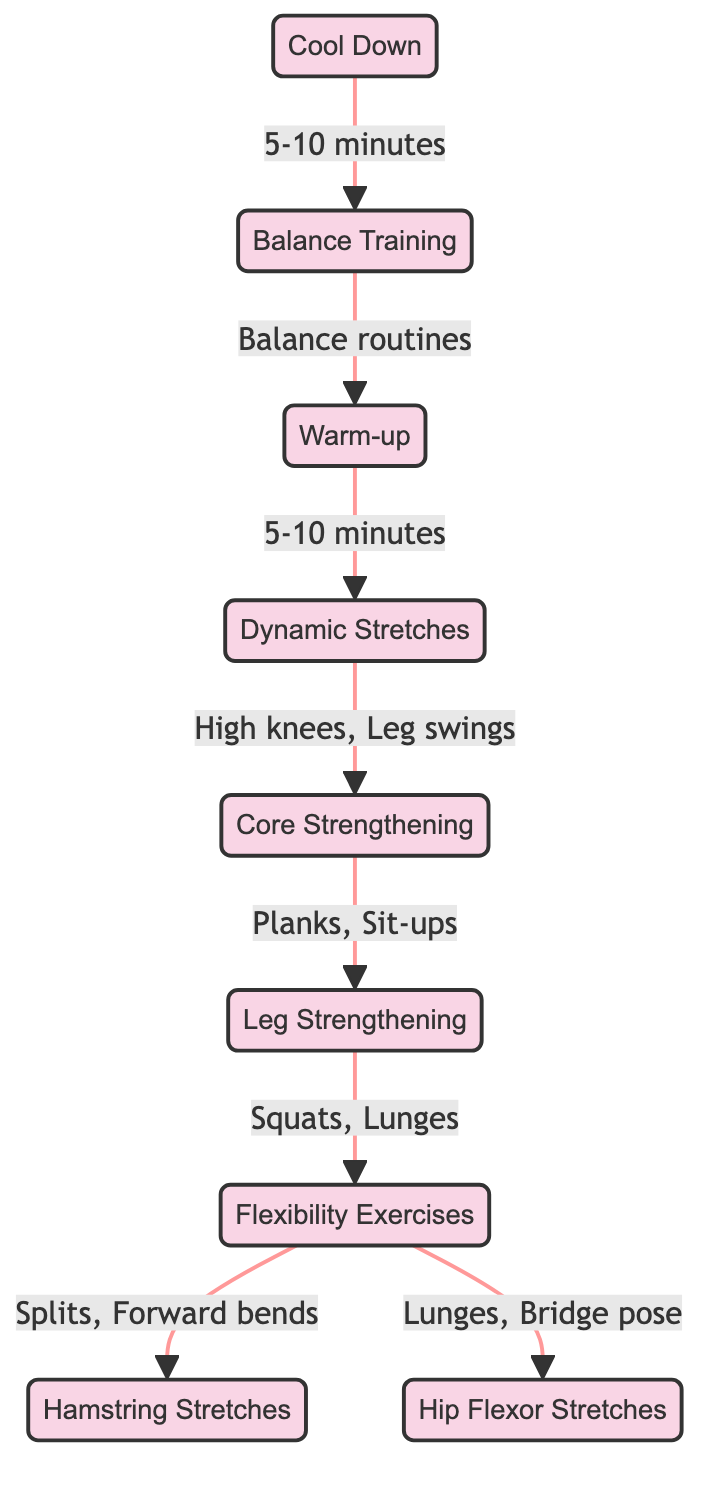What is the first step in the exercise routine? The diagram starts with the node labeled "Warm-up," indicating it is the first step in the routine.
Answer: Warm-up How many types of stretches are included in the routine? The diagram includes three types of stretches represented by the nodes: "Dynamic Stretches," "Hamstring Stretches," and "Hip Flexor Stretches." Counting these gives a total of three types.
Answer: 3 What exercise follows “Dynamic Stretches”? From the diagram, the arrow leads from "Dynamic Stretches" to "Core Strengthening," indicating it is the next step in the sequence.
Answer: Core Strengthening What exercises are included under "Leg Strengthening"? The node "Leg Strengthening" lists "Squats" and "Lunges" as the included exercises. Therefore, both are part of this step.
Answer: Squats, Lunges What is the total number of nodes in the diagram? By counting all the nodes listed in the diagram, there are a total of nine nodes: Warm-up, Dynamic Stretches, Core Strengthening, Leg Strengthening, Flexibility Exercises, Cool Down, Hamstring Stretches, Hip Flexor Stretches, and Balance Training.
Answer: 9 What is the duration suggested for "Cool Down"? The arrow indicates that "Cool Down" is followed by a duration of "5-10 minutes," which is specified in the diagram.
Answer: 5-10 minutes Which node connects back to "Warm-up"? The diagram shows that "Balance Training" connects back to "Warm-up," indicating a cyclical routine.
Answer: Balance Training What type of exercises are performed in "Flexibility Exercises"? The node indicates that the exercises under "Flexibility Exercises" are "Splits" and "Forward bends," showing the type of activities involved.
Answer: Splits, Forward bends 